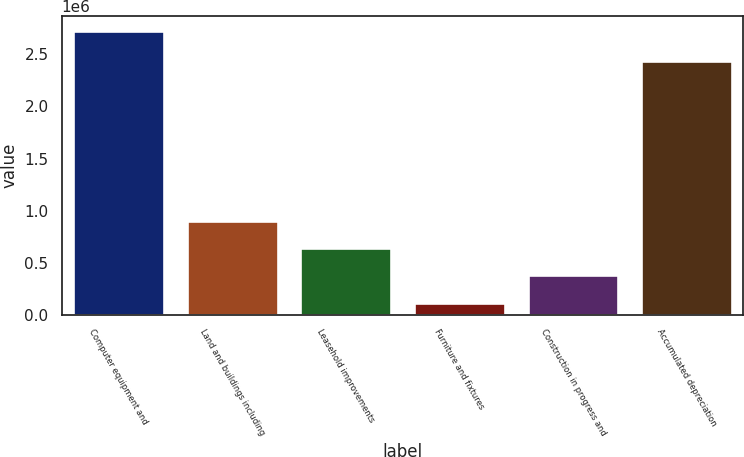Convert chart to OTSL. <chart><loc_0><loc_0><loc_500><loc_500><bar_chart><fcel>Computer equipment and<fcel>Land and buildings including<fcel>Leasehold improvements<fcel>Furniture and fixtures<fcel>Construction in progress and<fcel>Accumulated depreciation<nl><fcel>2.72974e+06<fcel>899832<fcel>638418<fcel>115588<fcel>377003<fcel>2.43945e+06<nl></chart> 